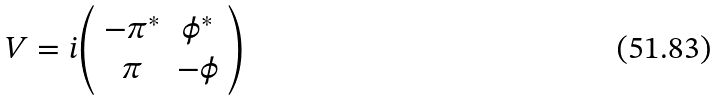Convert formula to latex. <formula><loc_0><loc_0><loc_500><loc_500>V = i { \left ( \begin{array} { c c } - \pi ^ { * } & \phi ^ { * } \\ \pi & - \phi \end{array} \right ) }</formula> 